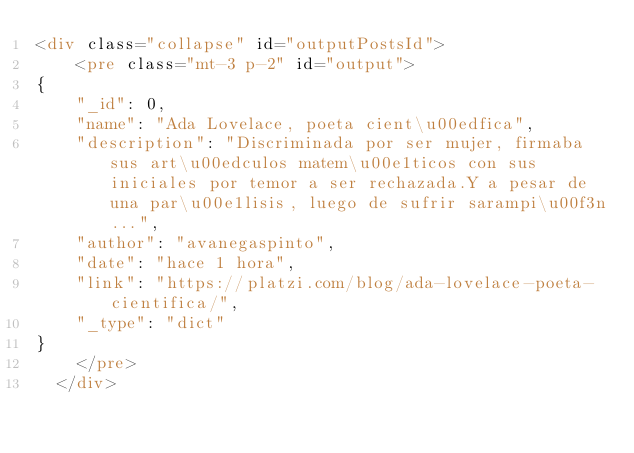<code> <loc_0><loc_0><loc_500><loc_500><_HTML_><div class="collapse" id="outputPostsId">
    <pre class="mt-3 p-2" id="output">
{
    "_id": 0, 
    "name": "Ada Lovelace, poeta cient\u00edfica", 
    "description": "Discriminada por ser mujer, firmaba sus art\u00edculos matem\u00e1ticos con sus iniciales por temor a ser rechazada.Y a pesar de una par\u00e1lisis, luego de sufrir sarampi\u00f3n...", 
    "author": "avanegaspinto", 
    "date": "hace 1 hora", 
    "link": "https://platzi.com/blog/ada-lovelace-poeta-cientifica/", 
    "_type": "dict"
}
    </pre>
  </div></code> 